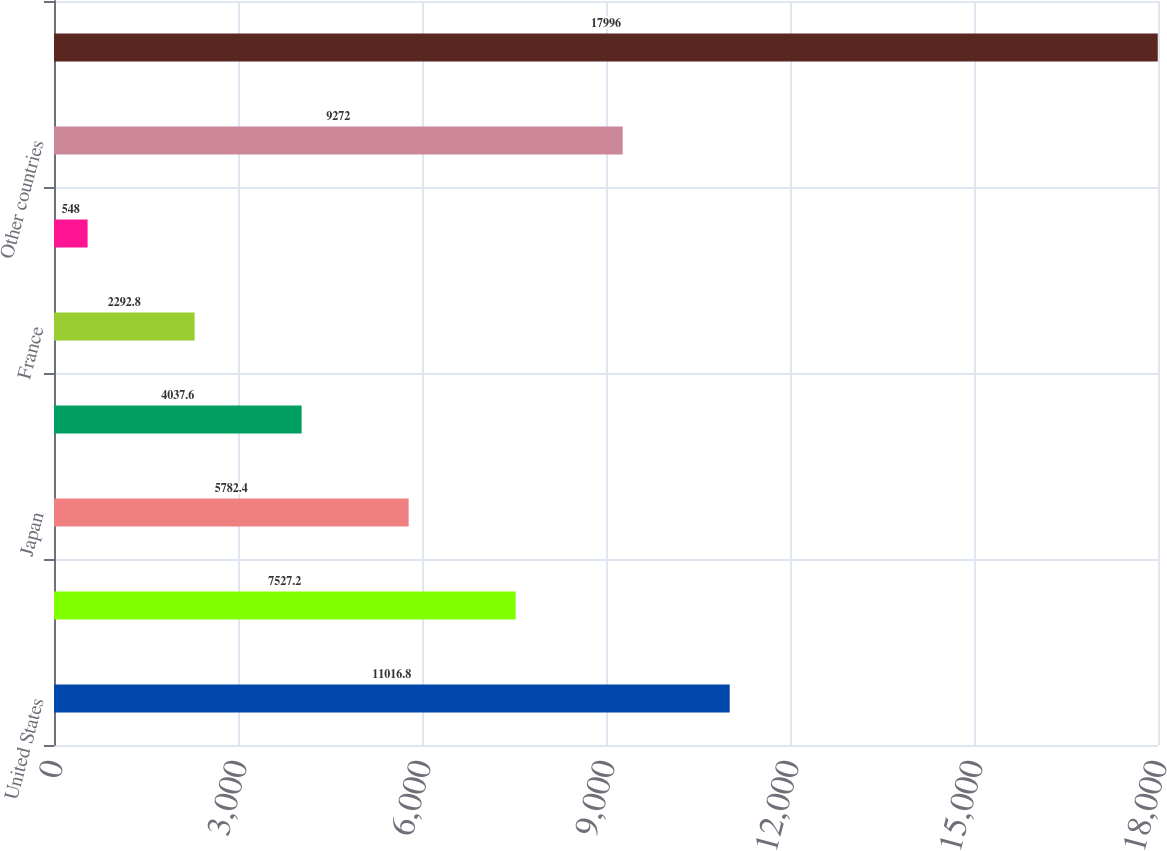Convert chart to OTSL. <chart><loc_0><loc_0><loc_500><loc_500><bar_chart><fcel>United States<fcel>United Kingdom<fcel>Japan<fcel>Germany<fcel>France<fcel>Canada<fcel>Other countries<fcel>Total<nl><fcel>11016.8<fcel>7527.2<fcel>5782.4<fcel>4037.6<fcel>2292.8<fcel>548<fcel>9272<fcel>17996<nl></chart> 